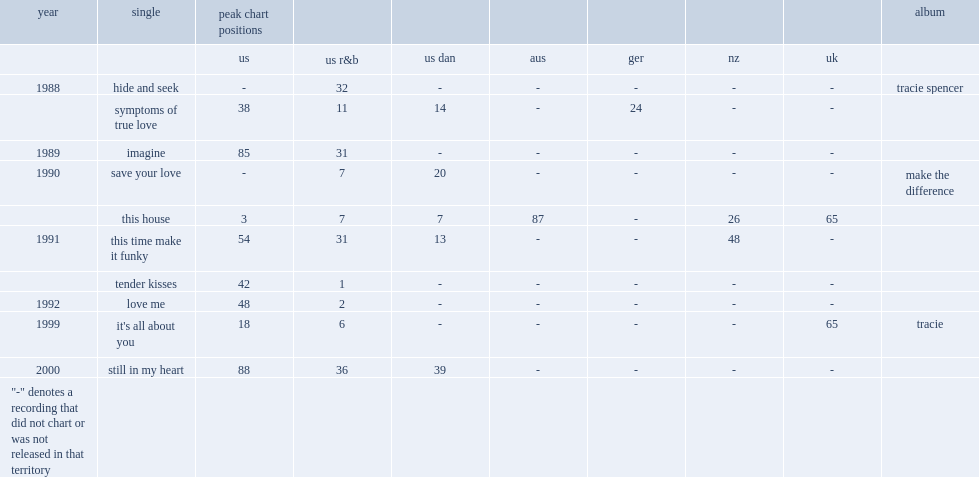When did "it's all about you (not about me)"release? 1999.0. 